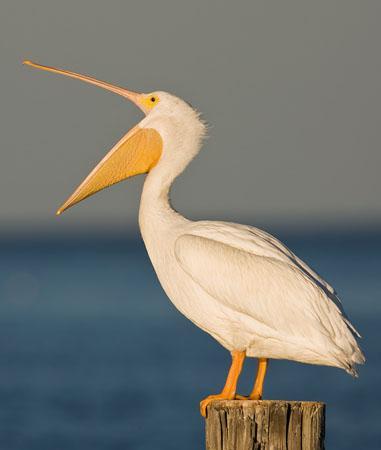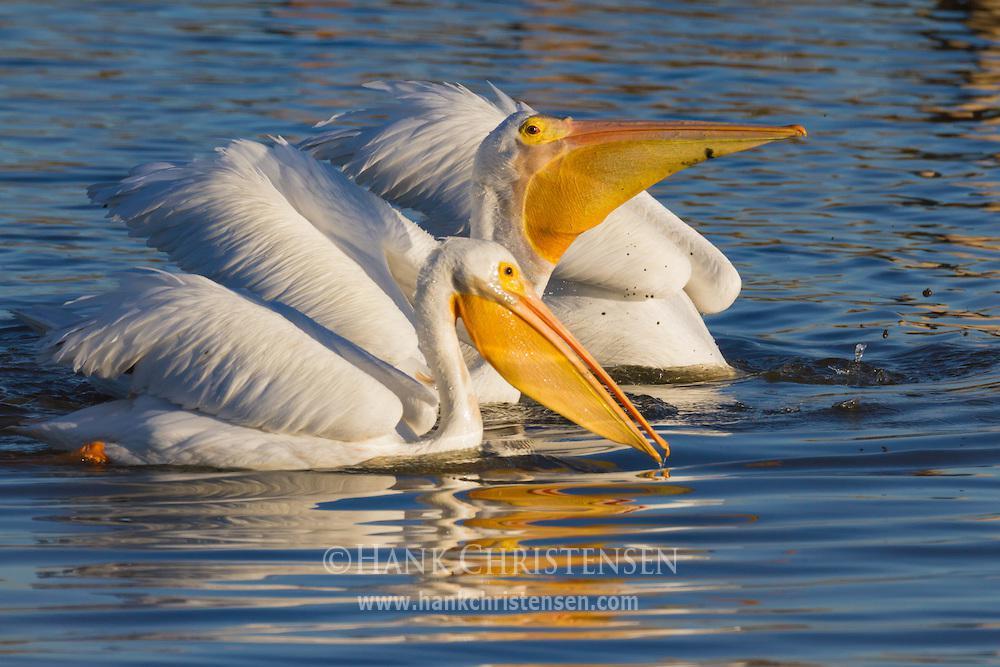The first image is the image on the left, the second image is the image on the right. Analyze the images presented: Is the assertion "Right image shows a dark gray bird with a sac-like expanded lower bill." valid? Answer yes or no. No. The first image is the image on the left, the second image is the image on the right. Considering the images on both sides, is "At least two fishes are in a bird's mouth." valid? Answer yes or no. No. 